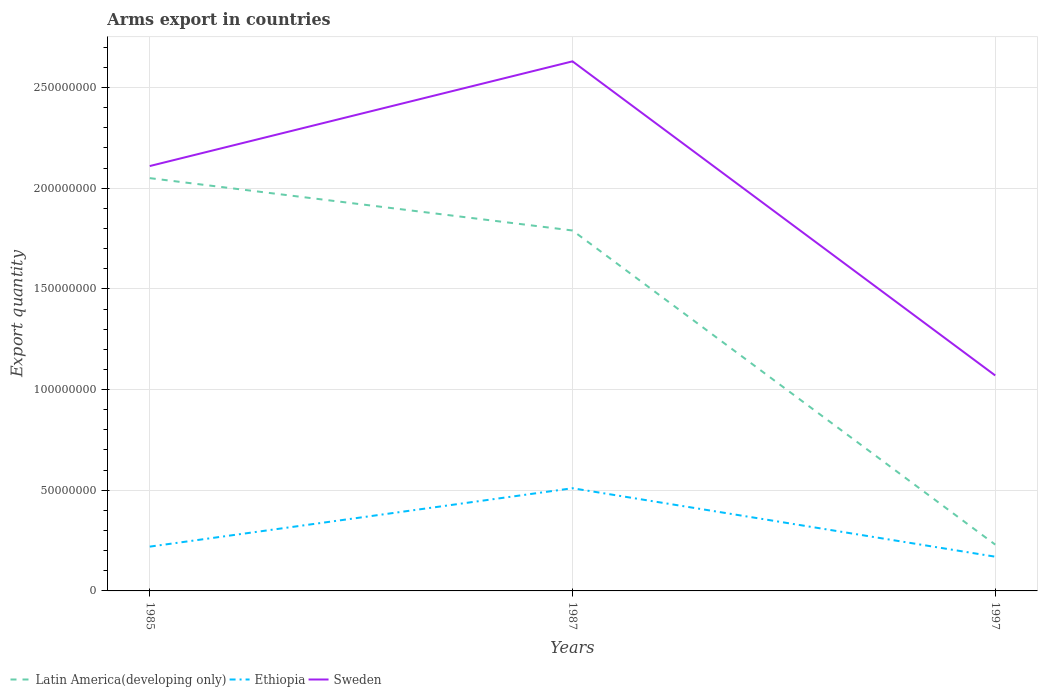Does the line corresponding to Sweden intersect with the line corresponding to Ethiopia?
Provide a succinct answer. No. Across all years, what is the maximum total arms export in Sweden?
Ensure brevity in your answer.  1.07e+08. What is the total total arms export in Ethiopia in the graph?
Provide a short and direct response. 5.00e+06. What is the difference between the highest and the second highest total arms export in Latin America(developing only)?
Your response must be concise. 1.82e+08. How many years are there in the graph?
Make the answer very short. 3. What is the difference between two consecutive major ticks on the Y-axis?
Make the answer very short. 5.00e+07. Does the graph contain any zero values?
Your answer should be compact. No. Does the graph contain grids?
Your answer should be compact. Yes. Where does the legend appear in the graph?
Offer a terse response. Bottom left. How many legend labels are there?
Provide a succinct answer. 3. What is the title of the graph?
Keep it short and to the point. Arms export in countries. Does "Canada" appear as one of the legend labels in the graph?
Offer a very short reply. No. What is the label or title of the X-axis?
Offer a terse response. Years. What is the label or title of the Y-axis?
Make the answer very short. Export quantity. What is the Export quantity of Latin America(developing only) in 1985?
Ensure brevity in your answer.  2.05e+08. What is the Export quantity of Ethiopia in 1985?
Give a very brief answer. 2.20e+07. What is the Export quantity of Sweden in 1985?
Provide a succinct answer. 2.11e+08. What is the Export quantity in Latin America(developing only) in 1987?
Ensure brevity in your answer.  1.79e+08. What is the Export quantity of Ethiopia in 1987?
Provide a succinct answer. 5.10e+07. What is the Export quantity in Sweden in 1987?
Provide a short and direct response. 2.63e+08. What is the Export quantity of Latin America(developing only) in 1997?
Your answer should be very brief. 2.30e+07. What is the Export quantity of Ethiopia in 1997?
Give a very brief answer. 1.70e+07. What is the Export quantity of Sweden in 1997?
Your answer should be very brief. 1.07e+08. Across all years, what is the maximum Export quantity of Latin America(developing only)?
Give a very brief answer. 2.05e+08. Across all years, what is the maximum Export quantity of Ethiopia?
Offer a terse response. 5.10e+07. Across all years, what is the maximum Export quantity of Sweden?
Ensure brevity in your answer.  2.63e+08. Across all years, what is the minimum Export quantity of Latin America(developing only)?
Provide a succinct answer. 2.30e+07. Across all years, what is the minimum Export quantity of Ethiopia?
Keep it short and to the point. 1.70e+07. Across all years, what is the minimum Export quantity in Sweden?
Provide a short and direct response. 1.07e+08. What is the total Export quantity in Latin America(developing only) in the graph?
Make the answer very short. 4.07e+08. What is the total Export quantity in Ethiopia in the graph?
Ensure brevity in your answer.  9.00e+07. What is the total Export quantity in Sweden in the graph?
Offer a very short reply. 5.81e+08. What is the difference between the Export quantity in Latin America(developing only) in 1985 and that in 1987?
Provide a succinct answer. 2.60e+07. What is the difference between the Export quantity of Ethiopia in 1985 and that in 1987?
Provide a succinct answer. -2.90e+07. What is the difference between the Export quantity of Sweden in 1985 and that in 1987?
Keep it short and to the point. -5.20e+07. What is the difference between the Export quantity of Latin America(developing only) in 1985 and that in 1997?
Your answer should be compact. 1.82e+08. What is the difference between the Export quantity in Sweden in 1985 and that in 1997?
Provide a short and direct response. 1.04e+08. What is the difference between the Export quantity in Latin America(developing only) in 1987 and that in 1997?
Your answer should be compact. 1.56e+08. What is the difference between the Export quantity in Ethiopia in 1987 and that in 1997?
Your answer should be very brief. 3.40e+07. What is the difference between the Export quantity in Sweden in 1987 and that in 1997?
Make the answer very short. 1.56e+08. What is the difference between the Export quantity in Latin America(developing only) in 1985 and the Export quantity in Ethiopia in 1987?
Provide a succinct answer. 1.54e+08. What is the difference between the Export quantity of Latin America(developing only) in 1985 and the Export quantity of Sweden in 1987?
Your response must be concise. -5.80e+07. What is the difference between the Export quantity of Ethiopia in 1985 and the Export quantity of Sweden in 1987?
Your response must be concise. -2.41e+08. What is the difference between the Export quantity in Latin America(developing only) in 1985 and the Export quantity in Ethiopia in 1997?
Your response must be concise. 1.88e+08. What is the difference between the Export quantity of Latin America(developing only) in 1985 and the Export quantity of Sweden in 1997?
Offer a terse response. 9.80e+07. What is the difference between the Export quantity of Ethiopia in 1985 and the Export quantity of Sweden in 1997?
Keep it short and to the point. -8.50e+07. What is the difference between the Export quantity in Latin America(developing only) in 1987 and the Export quantity in Ethiopia in 1997?
Offer a very short reply. 1.62e+08. What is the difference between the Export quantity in Latin America(developing only) in 1987 and the Export quantity in Sweden in 1997?
Offer a terse response. 7.20e+07. What is the difference between the Export quantity in Ethiopia in 1987 and the Export quantity in Sweden in 1997?
Your answer should be compact. -5.60e+07. What is the average Export quantity in Latin America(developing only) per year?
Give a very brief answer. 1.36e+08. What is the average Export quantity in Ethiopia per year?
Your answer should be compact. 3.00e+07. What is the average Export quantity of Sweden per year?
Offer a very short reply. 1.94e+08. In the year 1985, what is the difference between the Export quantity in Latin America(developing only) and Export quantity in Ethiopia?
Keep it short and to the point. 1.83e+08. In the year 1985, what is the difference between the Export quantity in Latin America(developing only) and Export quantity in Sweden?
Your response must be concise. -6.00e+06. In the year 1985, what is the difference between the Export quantity in Ethiopia and Export quantity in Sweden?
Your answer should be compact. -1.89e+08. In the year 1987, what is the difference between the Export quantity in Latin America(developing only) and Export quantity in Ethiopia?
Offer a very short reply. 1.28e+08. In the year 1987, what is the difference between the Export quantity of Latin America(developing only) and Export quantity of Sweden?
Offer a terse response. -8.40e+07. In the year 1987, what is the difference between the Export quantity in Ethiopia and Export quantity in Sweden?
Your response must be concise. -2.12e+08. In the year 1997, what is the difference between the Export quantity of Latin America(developing only) and Export quantity of Sweden?
Ensure brevity in your answer.  -8.40e+07. In the year 1997, what is the difference between the Export quantity of Ethiopia and Export quantity of Sweden?
Offer a terse response. -9.00e+07. What is the ratio of the Export quantity in Latin America(developing only) in 1985 to that in 1987?
Your response must be concise. 1.15. What is the ratio of the Export quantity of Ethiopia in 1985 to that in 1987?
Ensure brevity in your answer.  0.43. What is the ratio of the Export quantity of Sweden in 1985 to that in 1987?
Provide a succinct answer. 0.8. What is the ratio of the Export quantity in Latin America(developing only) in 1985 to that in 1997?
Provide a succinct answer. 8.91. What is the ratio of the Export quantity in Ethiopia in 1985 to that in 1997?
Provide a short and direct response. 1.29. What is the ratio of the Export quantity of Sweden in 1985 to that in 1997?
Ensure brevity in your answer.  1.97. What is the ratio of the Export quantity of Latin America(developing only) in 1987 to that in 1997?
Your answer should be compact. 7.78. What is the ratio of the Export quantity in Ethiopia in 1987 to that in 1997?
Offer a very short reply. 3. What is the ratio of the Export quantity of Sweden in 1987 to that in 1997?
Your answer should be very brief. 2.46. What is the difference between the highest and the second highest Export quantity in Latin America(developing only)?
Provide a succinct answer. 2.60e+07. What is the difference between the highest and the second highest Export quantity of Ethiopia?
Offer a very short reply. 2.90e+07. What is the difference between the highest and the second highest Export quantity of Sweden?
Your answer should be very brief. 5.20e+07. What is the difference between the highest and the lowest Export quantity in Latin America(developing only)?
Your answer should be very brief. 1.82e+08. What is the difference between the highest and the lowest Export quantity of Ethiopia?
Keep it short and to the point. 3.40e+07. What is the difference between the highest and the lowest Export quantity of Sweden?
Offer a very short reply. 1.56e+08. 